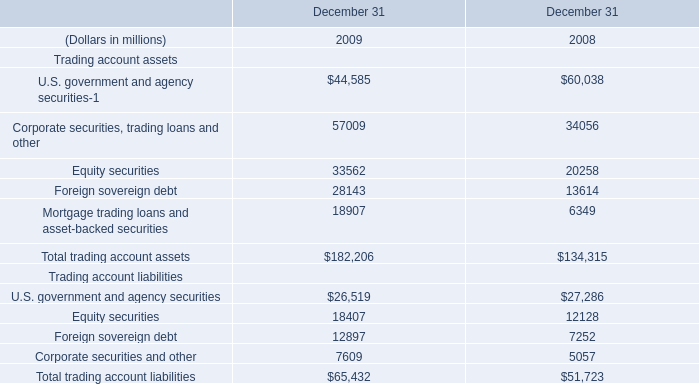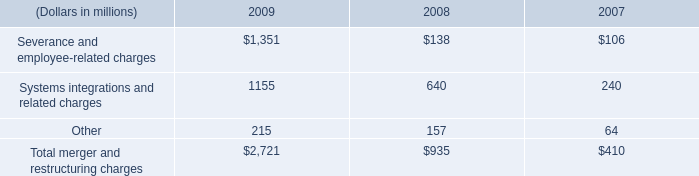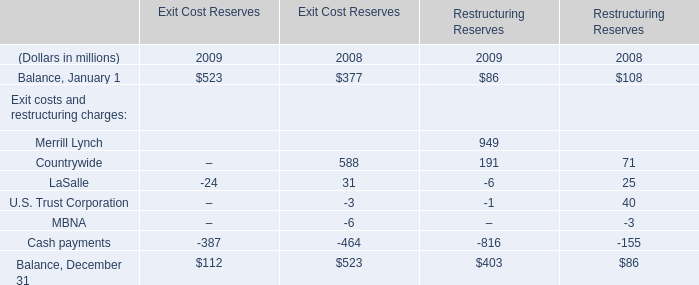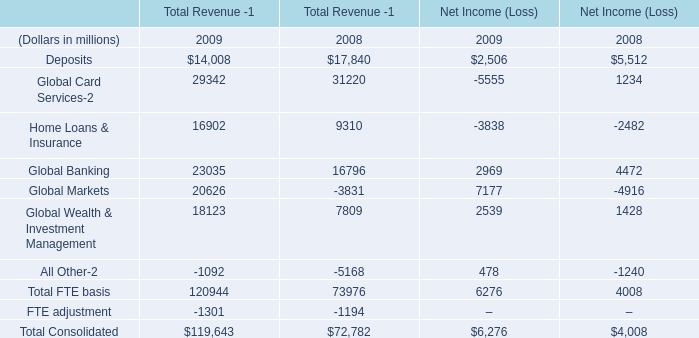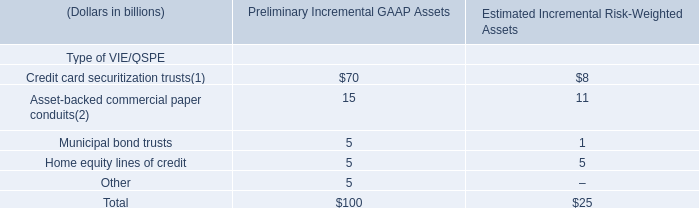What's the average of severance and employee-related charges and systems integrations and related charges in 2009? (in dollars in millions) 
Computations: ((1351 + 1155) / 2)
Answer: 1253.0. 